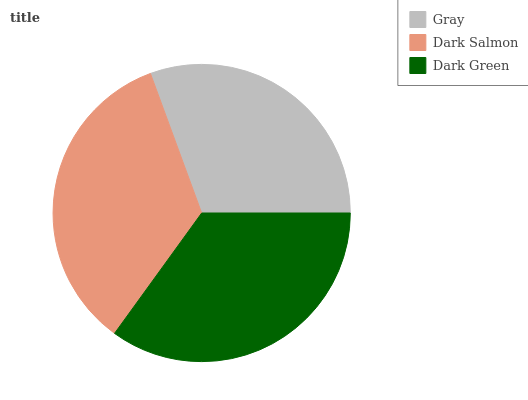Is Gray the minimum?
Answer yes or no. Yes. Is Dark Green the maximum?
Answer yes or no. Yes. Is Dark Salmon the minimum?
Answer yes or no. No. Is Dark Salmon the maximum?
Answer yes or no. No. Is Dark Salmon greater than Gray?
Answer yes or no. Yes. Is Gray less than Dark Salmon?
Answer yes or no. Yes. Is Gray greater than Dark Salmon?
Answer yes or no. No. Is Dark Salmon less than Gray?
Answer yes or no. No. Is Dark Salmon the high median?
Answer yes or no. Yes. Is Dark Salmon the low median?
Answer yes or no. Yes. Is Dark Green the high median?
Answer yes or no. No. Is Dark Green the low median?
Answer yes or no. No. 